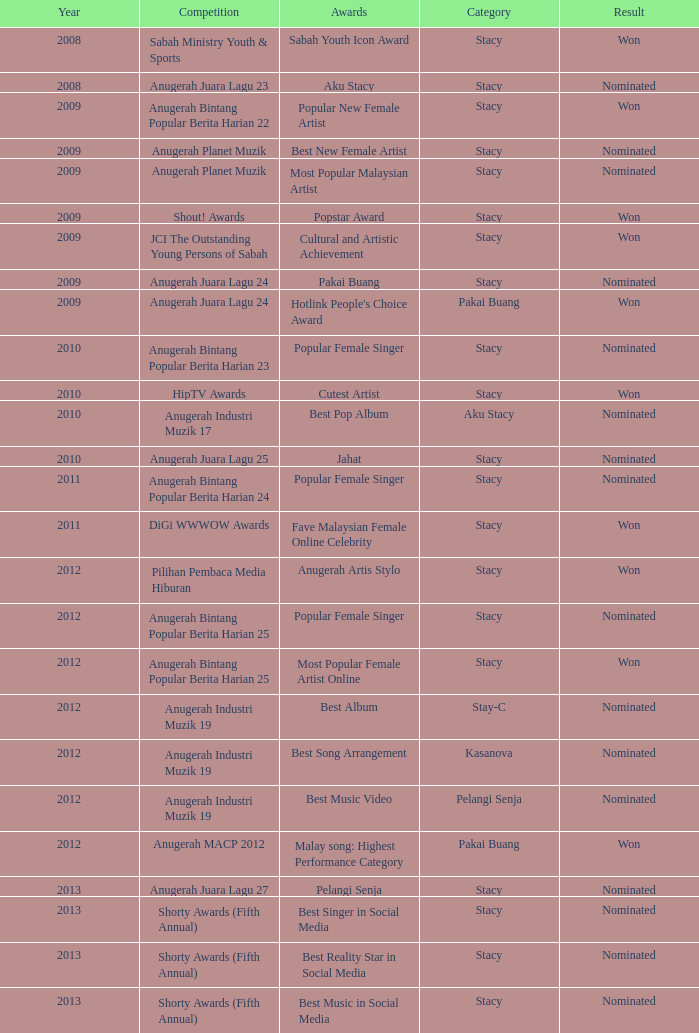What is the year associated with the 23rd edition of anugerah bintang popular berita harian competition? 1.0. 